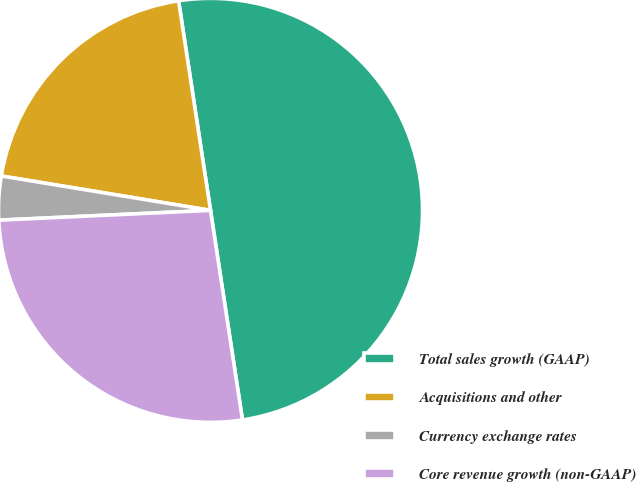Convert chart to OTSL. <chart><loc_0><loc_0><loc_500><loc_500><pie_chart><fcel>Total sales growth (GAAP)<fcel>Acquisitions and other<fcel>Currency exchange rates<fcel>Core revenue growth (non-GAAP)<nl><fcel>50.0%<fcel>20.0%<fcel>3.33%<fcel>26.67%<nl></chart> 